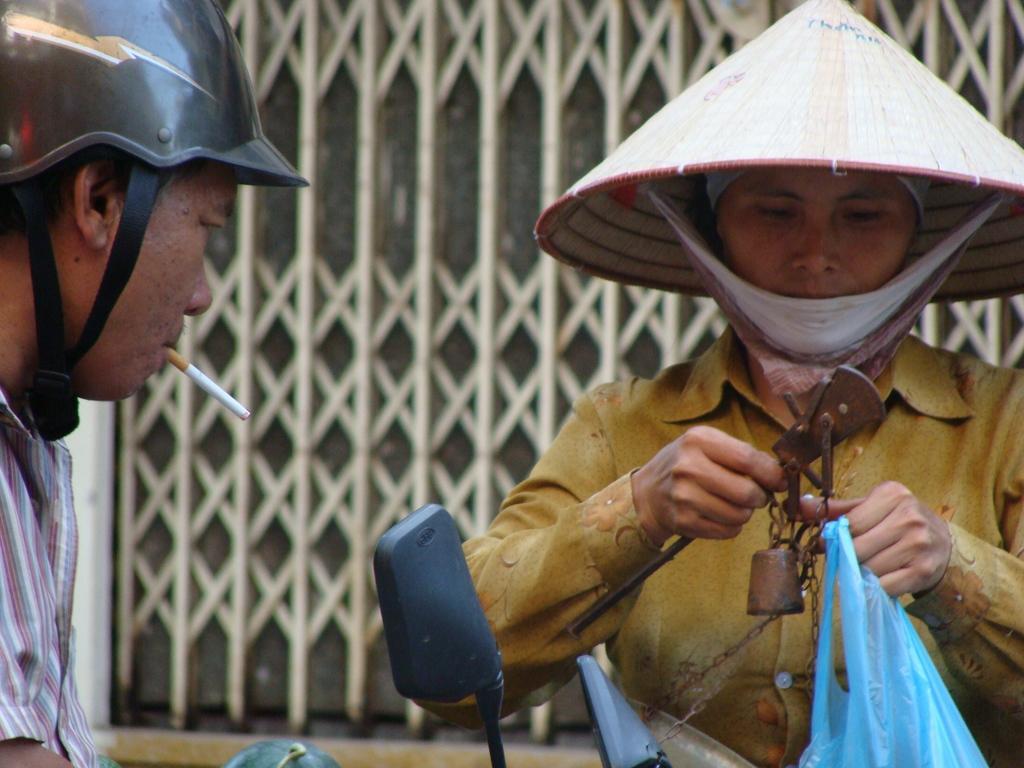Could you give a brief overview of what you see in this image? In this picture I can see a man in front and I see a cigarette in his mouth and on the right of this image I see a person who is holding things in her hands. In the background I see the gate. 